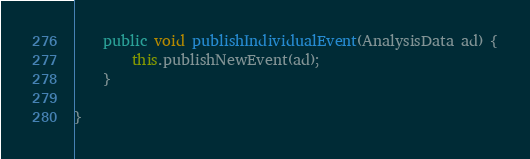Convert code to text. <code><loc_0><loc_0><loc_500><loc_500><_Java_>	public void publishIndividualEvent(AnalysisData ad) {
		this.publishNewEvent(ad);
	}

}
</code> 